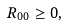Convert formula to latex. <formula><loc_0><loc_0><loc_500><loc_500>R _ { 0 0 } \geq 0 ,</formula> 